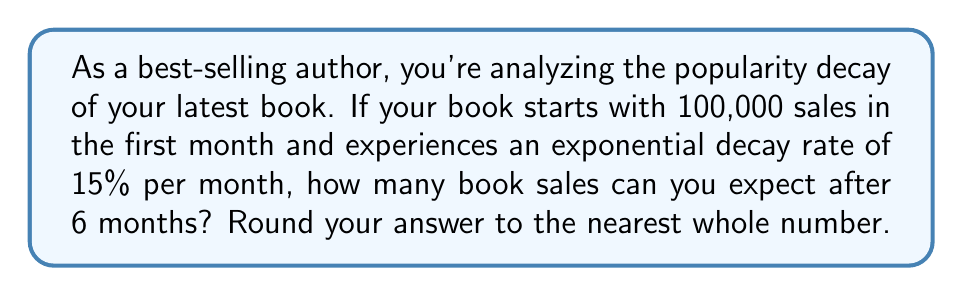Help me with this question. Let's approach this step-by-step using the exponential decay formula:

1) The exponential decay formula is:
   $$A = A_0 \cdot (1-r)^t$$
   Where:
   $A$ = Final amount
   $A_0$ = Initial amount
   $r$ = Decay rate (as a decimal)
   $t$ = Time periods

2) We have:
   $A_0 = 100,000$ (initial sales)
   $r = 0.15$ (15% decay rate)
   $t = 6$ (months)

3) Plugging these into our formula:
   $$A = 100,000 \cdot (1-0.15)^6$$

4) Simplify inside the parentheses:
   $$A = 100,000 \cdot (0.85)^6$$

5) Calculate the exponent:
   $$A = 100,000 \cdot 0.377695$$

6) Multiply:
   $$A = 37,769.5$$

7) Rounding to the nearest whole number:
   $$A \approx 37,770$$
Answer: 37,770 sales 